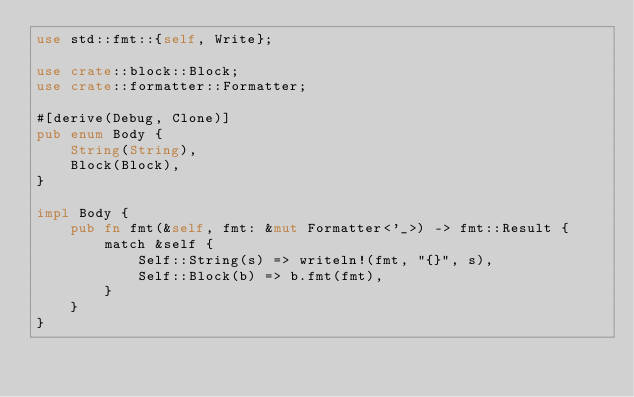Convert code to text. <code><loc_0><loc_0><loc_500><loc_500><_Rust_>use std::fmt::{self, Write};

use crate::block::Block;
use crate::formatter::Formatter;

#[derive(Debug, Clone)]
pub enum Body {
    String(String),
    Block(Block),
}

impl Body {
    pub fn fmt(&self, fmt: &mut Formatter<'_>) -> fmt::Result {
        match &self {
            Self::String(s) => writeln!(fmt, "{}", s),
            Self::Block(b) => b.fmt(fmt),
        }
    }
}
</code> 